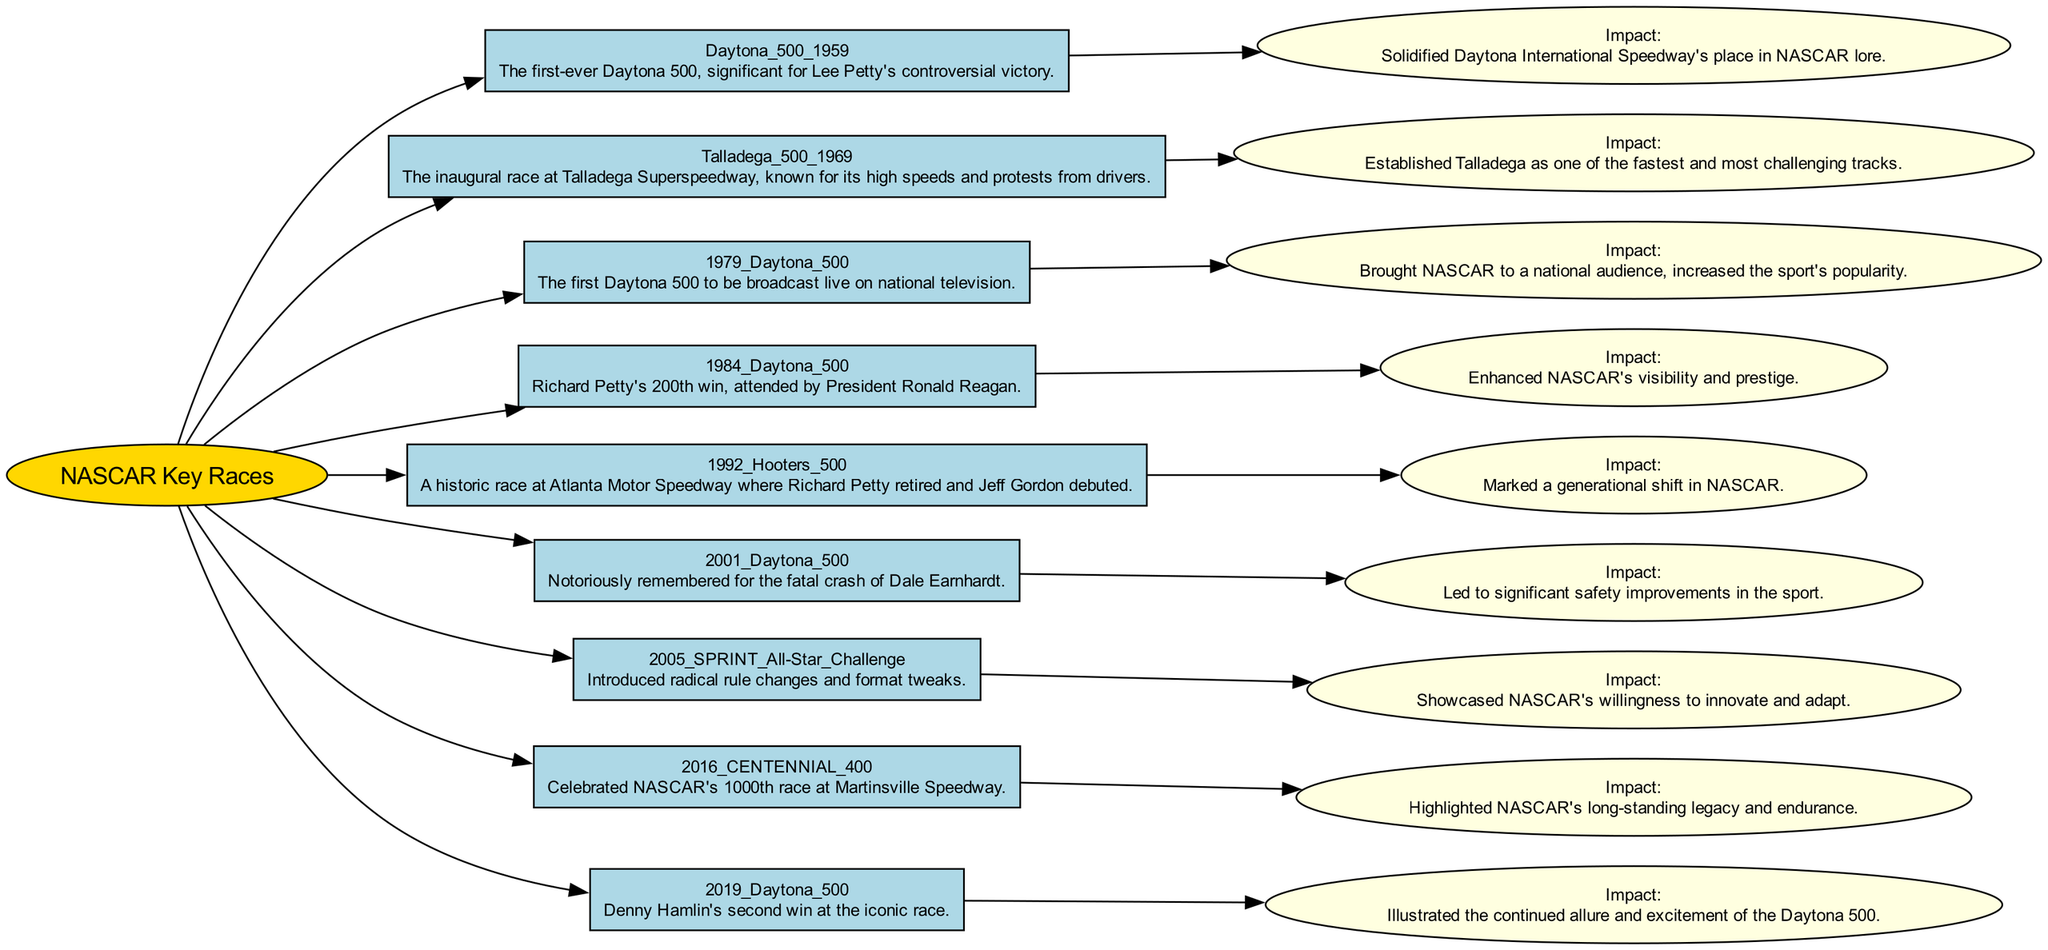What was the significance of the 1959 Daytona 500? The 1959 Daytona 500 was significant for being the first-ever Daytona 500, with Lee Petty's controversial victory solidifying Daytona International Speedway's place in NASCAR lore.
Answer: First-ever Daytona 500 How many races are listed in the concept map? The concept map contains nine key NASCAR races that shaped the sport's history, each represented as a node connected to the main NASCAR node.
Answer: Nine Which race marked a generational shift in NASCAR? The 1992 Hooters 500 marked a generational shift in NASCAR due to Richard Petty's retirement and Jeff Gordon's debut, highlighting a transition in the sport's history.
Answer: 1992 Hooters 500 What was the impact of the 2001 Daytona 500? The impact of the 2001 Daytona 500 was significant in that it led to substantial safety improvements in the sport, following the fatal crash of Dale Earnhardt during the race.
Answer: Significant safety improvements Which race was attended by President Ronald Reagan? The 1984 Daytona 500 was attended by President Ronald Reagan, which enhanced NASCAR's visibility and prestige during that time.
Answer: 1984 Daytona 500 What was introduced during the 2005 SPRINT All-Star Challenge? The 2005 SPRINT All-Star Challenge introduced radical rule changes and format tweaks, showcasing NASCAR's willingness to innovate and adapt over time.
Answer: Radical rule changes What event led to the increased popularity of NASCAR on a national level? The 1979 Daytona 500 was the first Daytona 500 to be broadcast live on national television, which significantly increased the sport's popularity and outreach.
Answer: Broadcast live on national television What race highlighted NASCAR's long-standing legacy? The 2016 Centennial 400 celebrated NASCAR's 1000th race at Martinsville Speedway, highlighting the sport's endurance and long-standing legacy.
Answer: 2016 Centennial 400 What did Denny Hamlin achieve in the 2019 Daytona 500? In the 2019 Daytona 500, Denny Hamlin secured his second victory at the iconic race, illustrating the continued allure and excitement of the Daytona 500.
Answer: Second victory at Daytona 500 